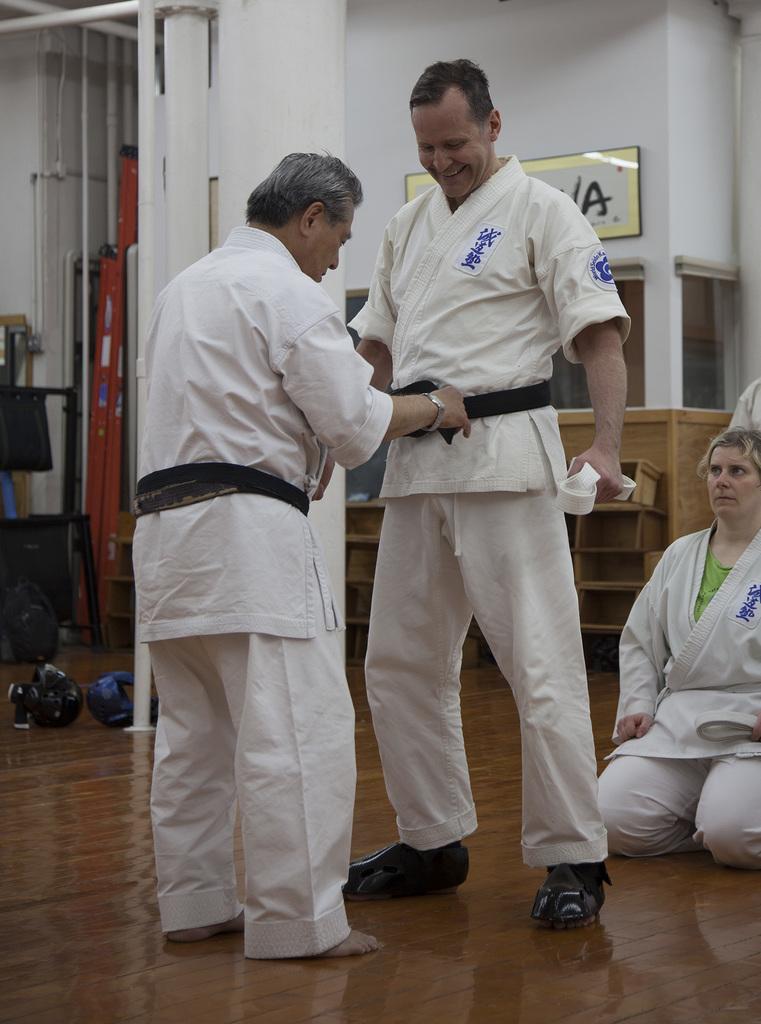What letter can be seen on the poster on the wall?
Ensure brevity in your answer.  A. 